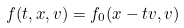<formula> <loc_0><loc_0><loc_500><loc_500>f ( t , x , v ) = f _ { 0 } ( x - t v , v )</formula> 